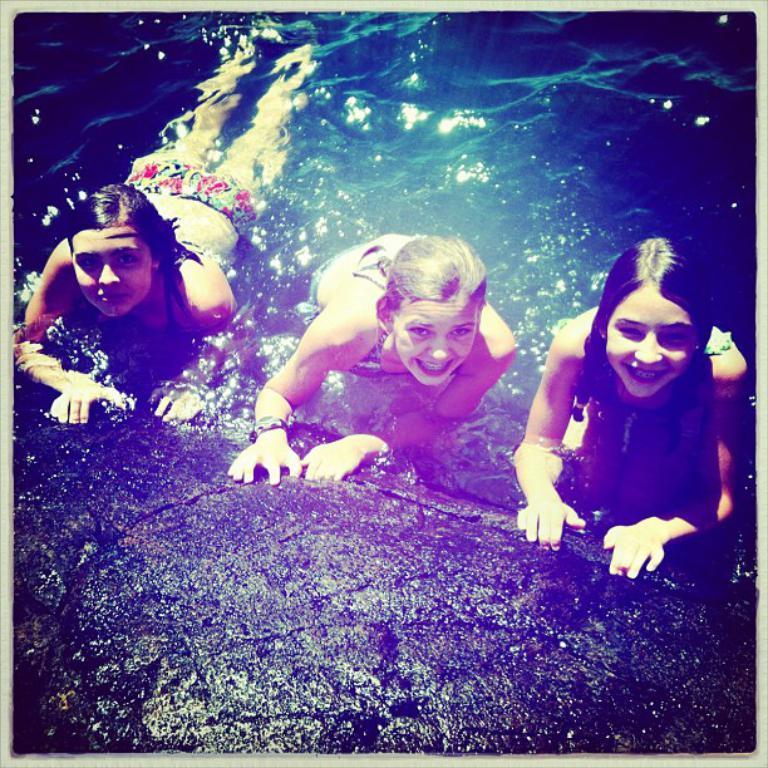In one or two sentences, can you explain what this image depicts? In this picture we can see three girls smiling, at the bottom there is water. 